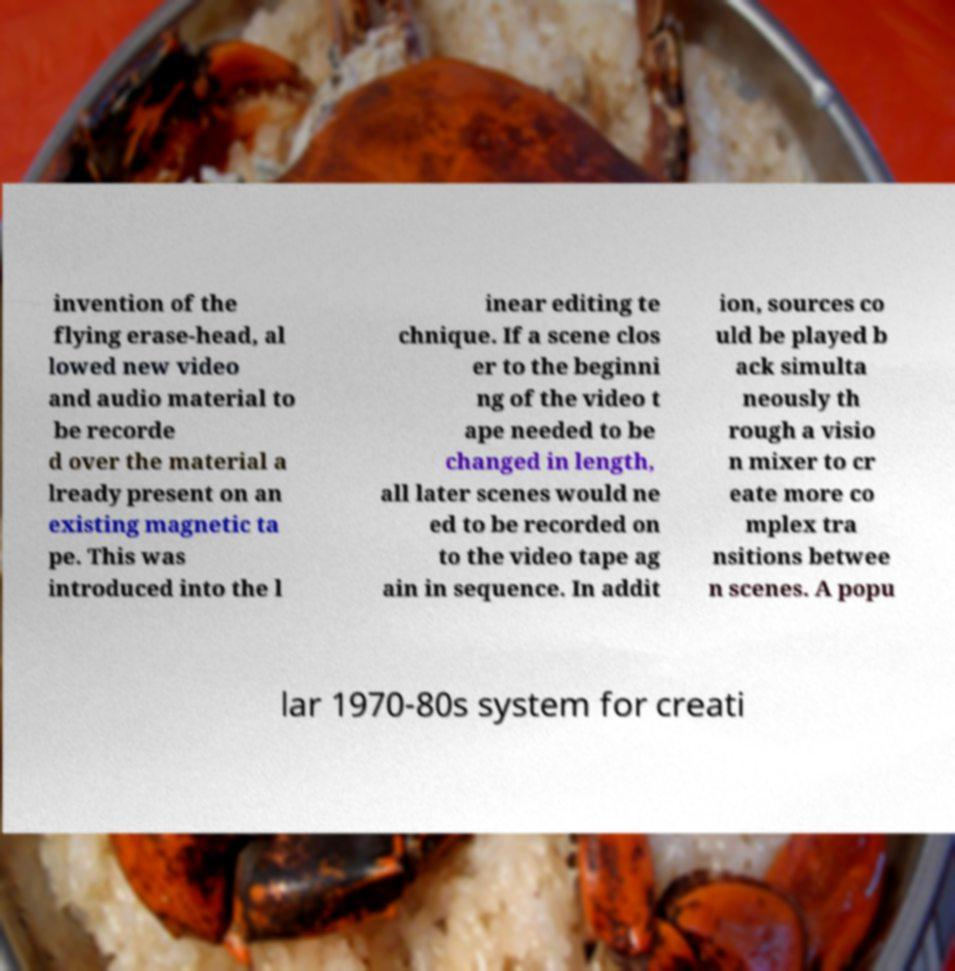Could you extract and type out the text from this image? invention of the flying erase-head, al lowed new video and audio material to be recorde d over the material a lready present on an existing magnetic ta pe. This was introduced into the l inear editing te chnique. If a scene clos er to the beginni ng of the video t ape needed to be changed in length, all later scenes would ne ed to be recorded on to the video tape ag ain in sequence. In addit ion, sources co uld be played b ack simulta neously th rough a visio n mixer to cr eate more co mplex tra nsitions betwee n scenes. A popu lar 1970-80s system for creati 